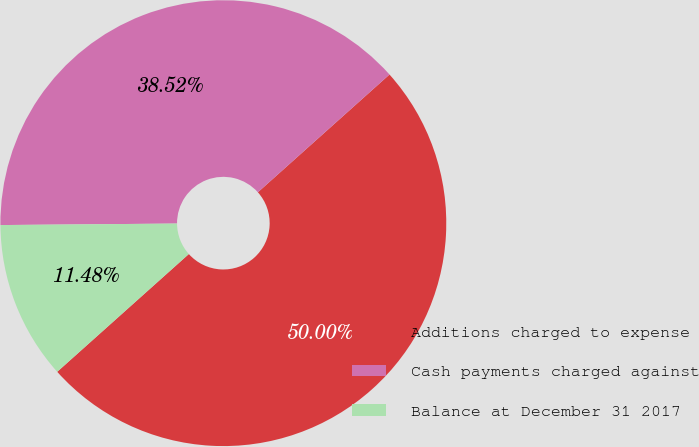Convert chart. <chart><loc_0><loc_0><loc_500><loc_500><pie_chart><fcel>Additions charged to expense<fcel>Cash payments charged against<fcel>Balance at December 31 2017<nl><fcel>50.0%<fcel>38.52%<fcel>11.48%<nl></chart> 